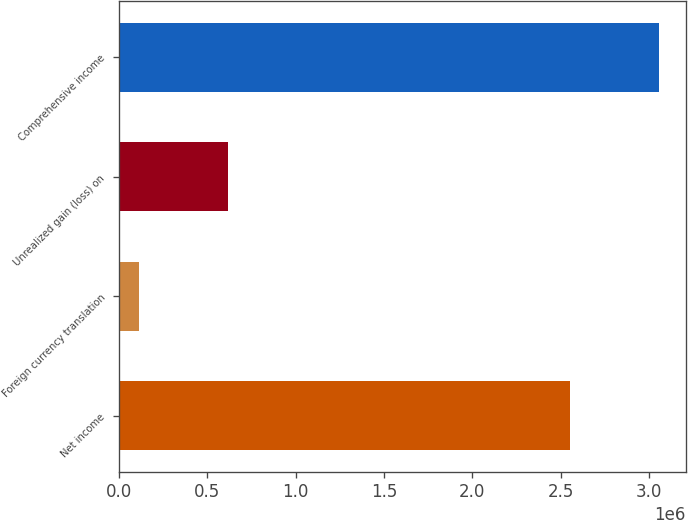Convert chart to OTSL. <chart><loc_0><loc_0><loc_500><loc_500><bar_chart><fcel>Net income<fcel>Foreign currency translation<fcel>Unrealized gain (loss) on<fcel>Comprehensive income<nl><fcel>2.55136e+06<fcel>114505<fcel>619259<fcel>3.05611e+06<nl></chart> 